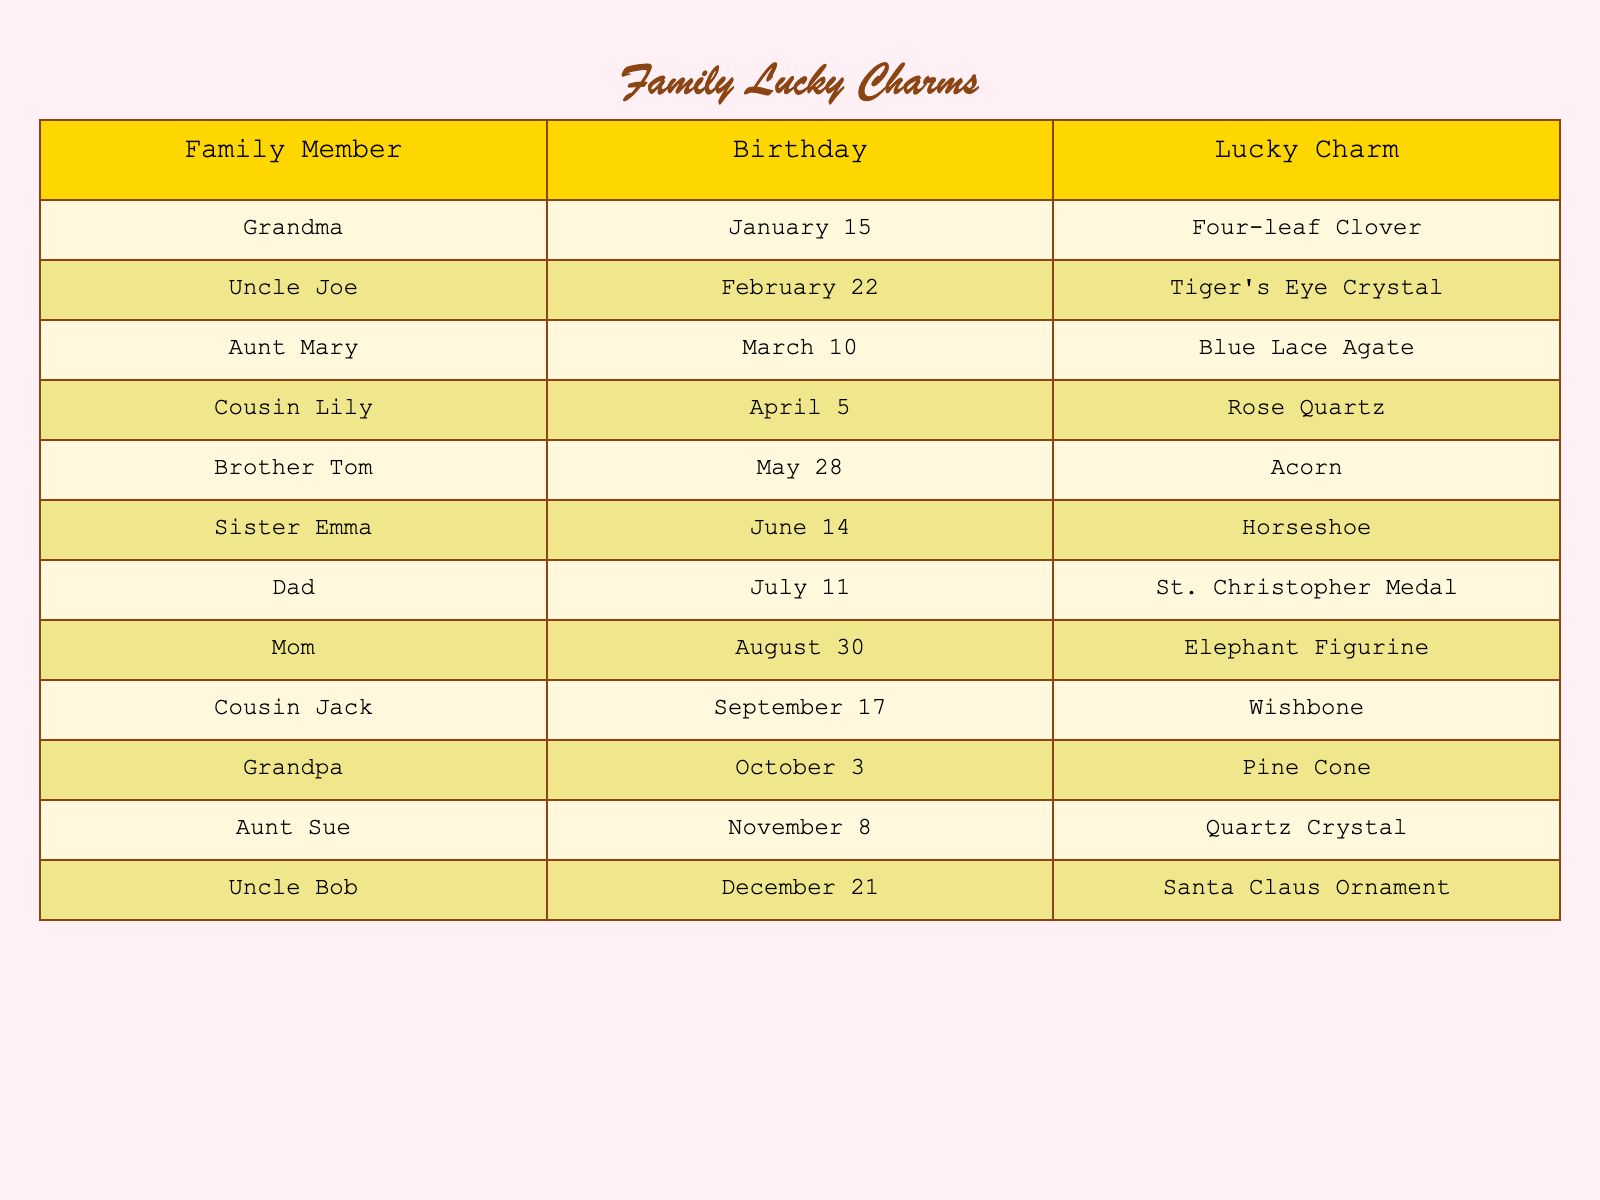What is the lucky charm for Cousin Lily? In the table, I look for the row with Cousin Lily. The corresponding lucky charm listed under her name is Rose Quartz.
Answer: Rose Quartz Which family member has a birthday in April? I check the table for the month of April, and I find that Cousin Lily's birthday is on April 5.
Answer: Cousin Lily True or False: Uncle Bob's lucky charm is a Christmas tree ornament. I look at Uncle Bob's row in the table, which states that his lucky charm is a Santa Claus Ornament, not a Christmas tree ornament. Thus, the statement is false.
Answer: False Who has the earliest birthday in the family? Starting from the first month of the year, I check the table and find Grandma's birthday on January 15, which is earlier than any other listed birthdays.
Answer: Grandma If you combine the birthdays in June and July, which month has the higher total? June has Sister Emma's birthday on June 14 and July has Dad's birthday on July 11. I find that June has a total of 14 and July has a total of 11, so June is greater.
Answer: June What is the lucky charm associated with Grandpa? I find the row for Grandpa and see that his lucky charm is listed as a Pine Cone.
Answer: Pine Cone Does Aunt Mary share her birthday month with any other family member? I look to see if there are any other birthdays in March. Aunt Mary has a birthday on March 10, and no other names appear in the March column, which means she does not share her month with anyone else.
Answer: No Which lucky charm is associated with the family member who celebrates their birthday in August? I check the August row and see that Mom celebrates her birthday on August 30, and her lucky charm is an Elephant Figurine.
Answer: Elephant Figurine How many family members have their birthdays in the second half of the year? I check the table from July to December: Dad in July, Mom in August, Cousin Jack in September, Grandpa in October, Aunt Sue in November, and Uncle Bob in December. That's six family members in the second half of the year.
Answer: 6 